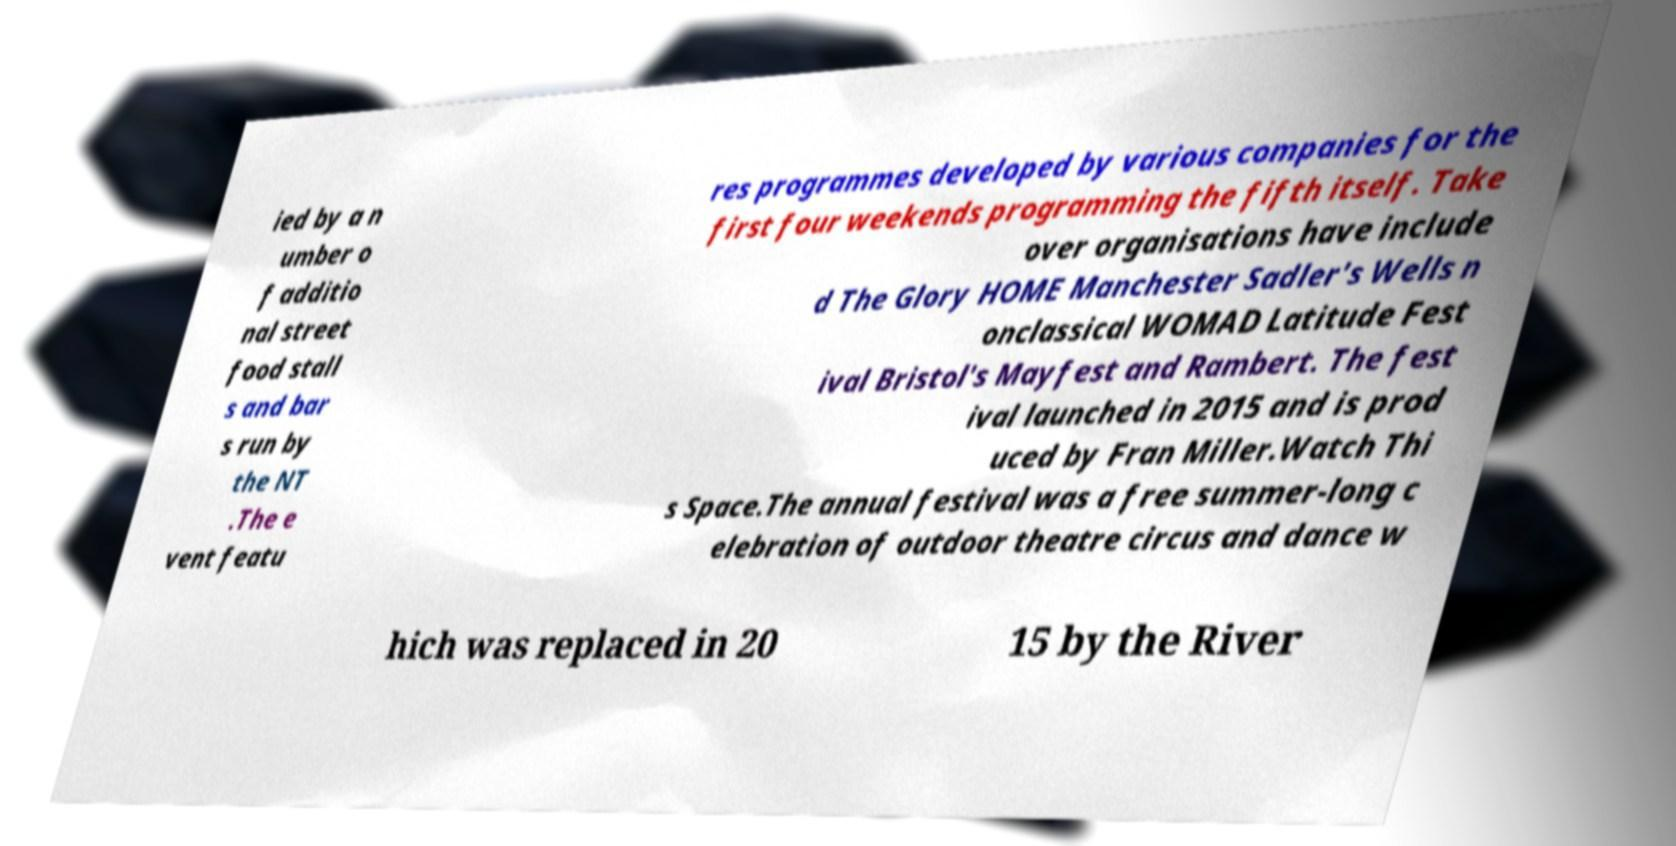Could you extract and type out the text from this image? ied by a n umber o f additio nal street food stall s and bar s run by the NT .The e vent featu res programmes developed by various companies for the first four weekends programming the fifth itself. Take over organisations have include d The Glory HOME Manchester Sadler's Wells n onclassical WOMAD Latitude Fest ival Bristol's Mayfest and Rambert. The fest ival launched in 2015 and is prod uced by Fran Miller.Watch Thi s Space.The annual festival was a free summer-long c elebration of outdoor theatre circus and dance w hich was replaced in 20 15 by the River 